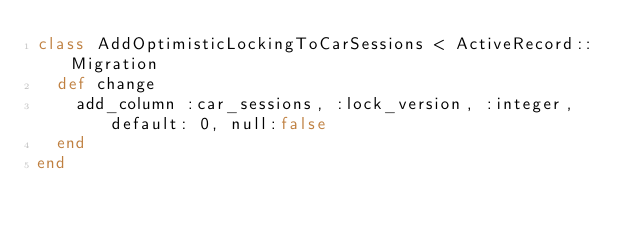Convert code to text. <code><loc_0><loc_0><loc_500><loc_500><_Ruby_>class AddOptimisticLockingToCarSessions < ActiveRecord::Migration
  def change
    add_column :car_sessions, :lock_version, :integer, default: 0, null:false
  end
end
</code> 